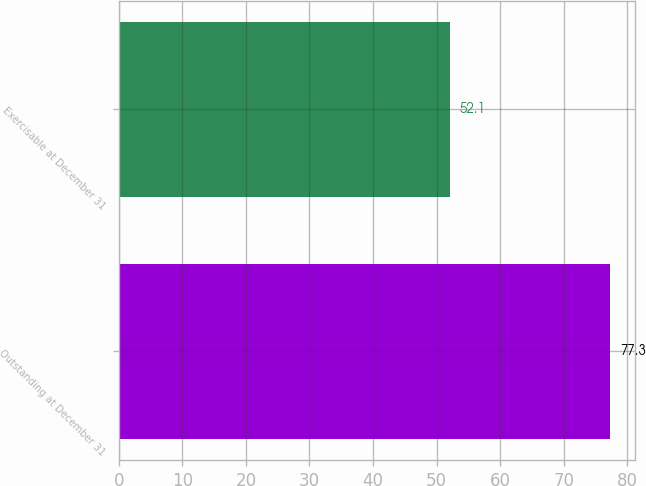Convert chart. <chart><loc_0><loc_0><loc_500><loc_500><bar_chart><fcel>Outstanding at December 31<fcel>Exercisable at December 31<nl><fcel>77.3<fcel>52.1<nl></chart> 